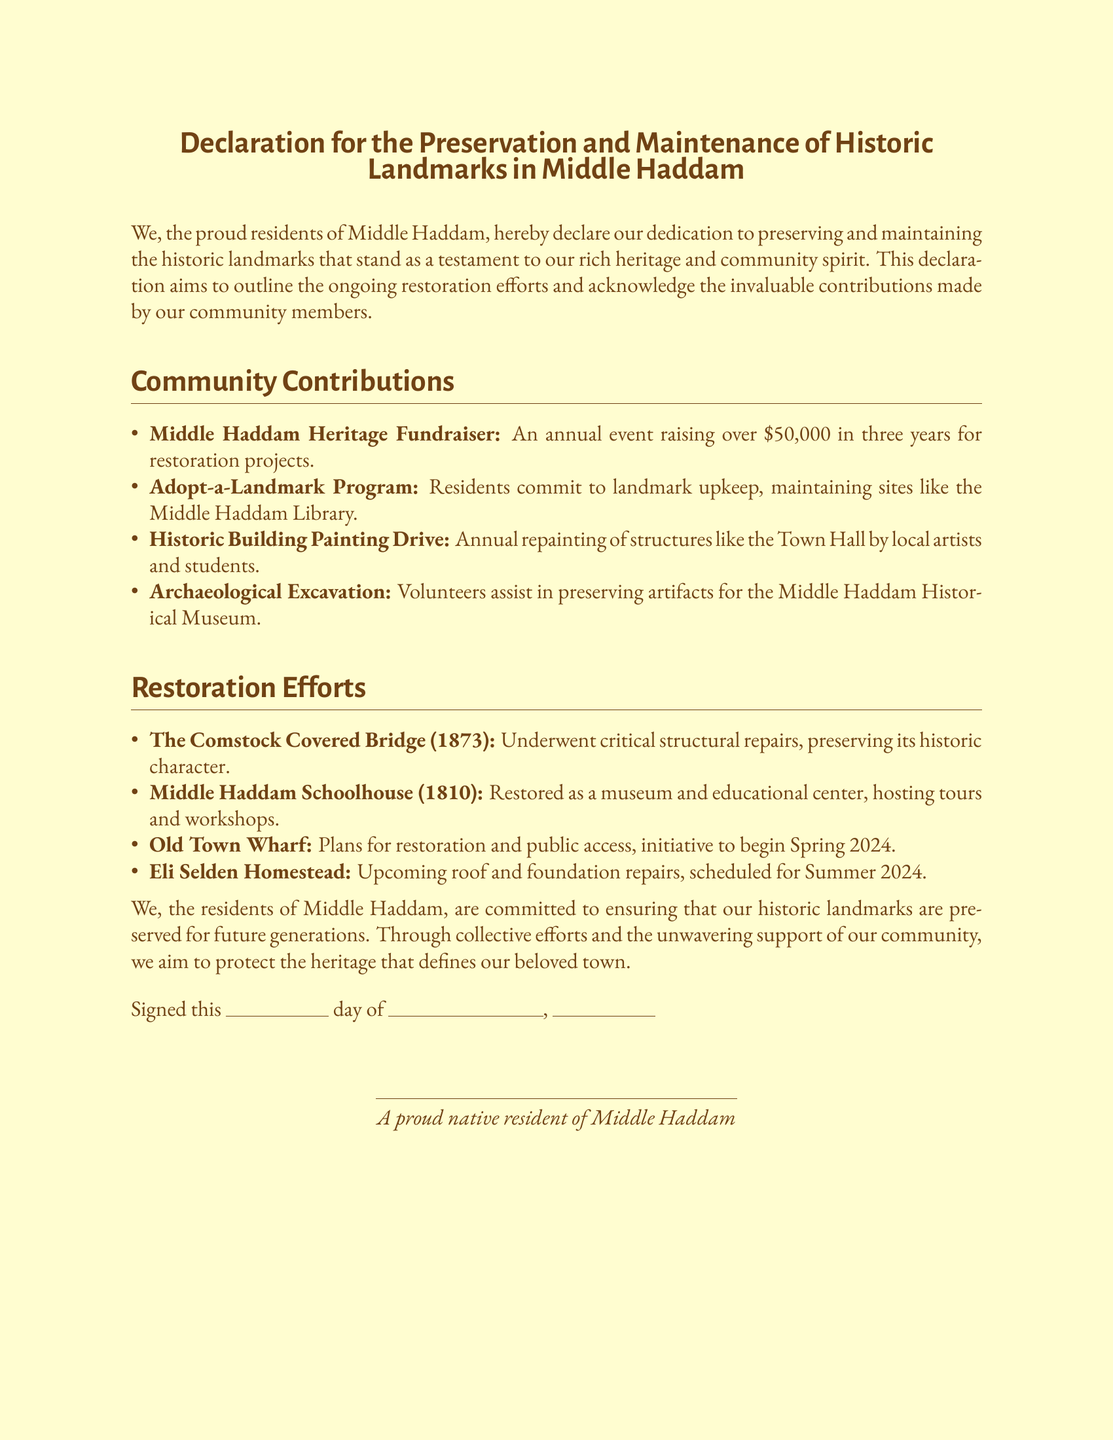What is the name of the annual fundraising event? The document mentions an annual event called the Middle Haddam Heritage Fundraiser, which raises money for restoration projects.
Answer: Middle Haddam Heritage Fundraiser How much money has been raised by the fundraiser in three years? The document states that the Middle Haddam Heritage Fundraiser has raised over $50,000 in three years.
Answer: Over $50,000 What is the purpose of the Adopt-a-Landmark Program? The document describes this program as a commitment from residents to maintain landmarks, such as the Middle Haddam Library.
Answer: Upkeep of landmarks When are the planned restorations for the Old Town Wharf scheduled to begin? According to the document, the initiative for the Old Town Wharf restoration is set to begin in Spring 2024.
Answer: Spring 2024 What historic structure is scheduled for roof and foundation repairs? The document mentions the Eli Selden Homestead as the structure that is upcoming for these repairs.
Answer: Eli Selden Homestead What year was the Comstock Covered Bridge built? The document indicates that the Comstock Covered Bridge was built in 1873.
Answer: 1873 What type of efforts does this declaration focus on? The document explicitly states that it focuses on the preservation and maintenance of historic landmarks.
Answer: Preservation and maintenance What will the Middle Haddam Schoolhouse serve as after restoration? The document explains that the Middle Haddam Schoolhouse is restored to function as a museum and educational center.
Answer: Museum and educational center What is the primary goal of the residents' commitment? The document emphasizes that the residents are committed to preserving their historic landmarks for future generations.
Answer: Preserve for future generations 